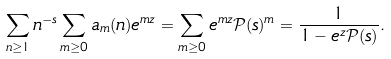Convert formula to latex. <formula><loc_0><loc_0><loc_500><loc_500>\sum _ { n \geq 1 } n ^ { - s } \sum _ { m \geq 0 } a _ { m } ( n ) e ^ { m z } = \sum _ { m \geq 0 } e ^ { m z } \mathcal { P } ( s ) ^ { m } = \frac { 1 } { 1 - e ^ { z } \mathcal { P } ( s ) } .</formula> 